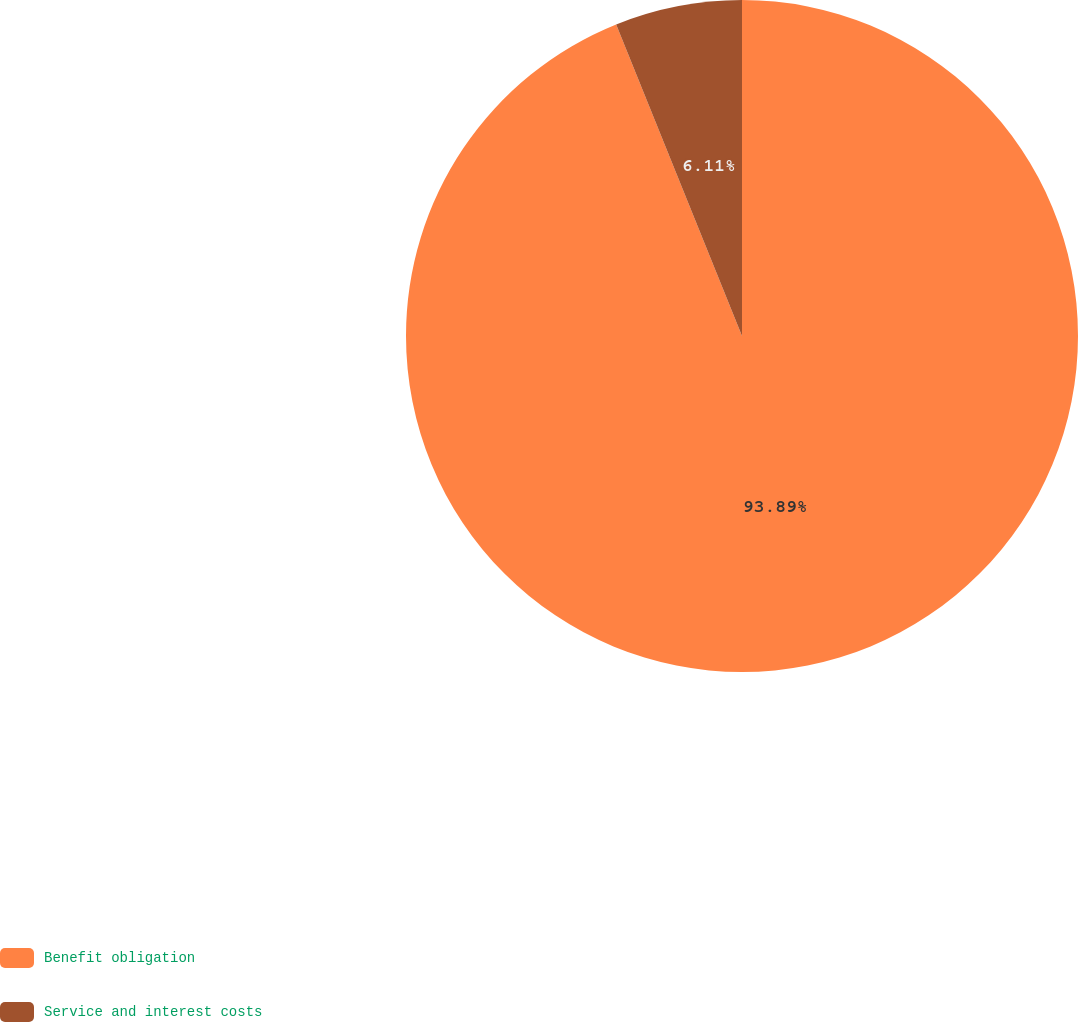<chart> <loc_0><loc_0><loc_500><loc_500><pie_chart><fcel>Benefit obligation<fcel>Service and interest costs<nl><fcel>93.89%<fcel>6.11%<nl></chart> 